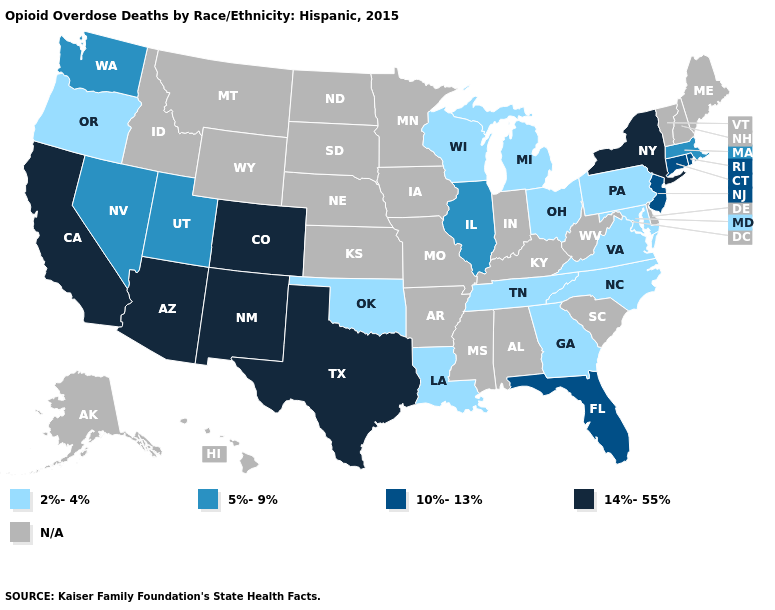Among the states that border Massachusetts , does Connecticut have the highest value?
Short answer required. No. Name the states that have a value in the range 2%-4%?
Answer briefly. Georgia, Louisiana, Maryland, Michigan, North Carolina, Ohio, Oklahoma, Oregon, Pennsylvania, Tennessee, Virginia, Wisconsin. Does the first symbol in the legend represent the smallest category?
Short answer required. Yes. Among the states that border Kansas , which have the highest value?
Quick response, please. Colorado. What is the highest value in the MidWest ?
Concise answer only. 5%-9%. Name the states that have a value in the range N/A?
Quick response, please. Alabama, Alaska, Arkansas, Delaware, Hawaii, Idaho, Indiana, Iowa, Kansas, Kentucky, Maine, Minnesota, Mississippi, Missouri, Montana, Nebraska, New Hampshire, North Dakota, South Carolina, South Dakota, Vermont, West Virginia, Wyoming. What is the value of Mississippi?
Short answer required. N/A. What is the value of Connecticut?
Be succinct. 10%-13%. Name the states that have a value in the range 2%-4%?
Write a very short answer. Georgia, Louisiana, Maryland, Michigan, North Carolina, Ohio, Oklahoma, Oregon, Pennsylvania, Tennessee, Virginia, Wisconsin. What is the value of Mississippi?
Write a very short answer. N/A. Name the states that have a value in the range 2%-4%?
Keep it brief. Georgia, Louisiana, Maryland, Michigan, North Carolina, Ohio, Oklahoma, Oregon, Pennsylvania, Tennessee, Virginia, Wisconsin. What is the highest value in the Northeast ?
Answer briefly. 14%-55%. 